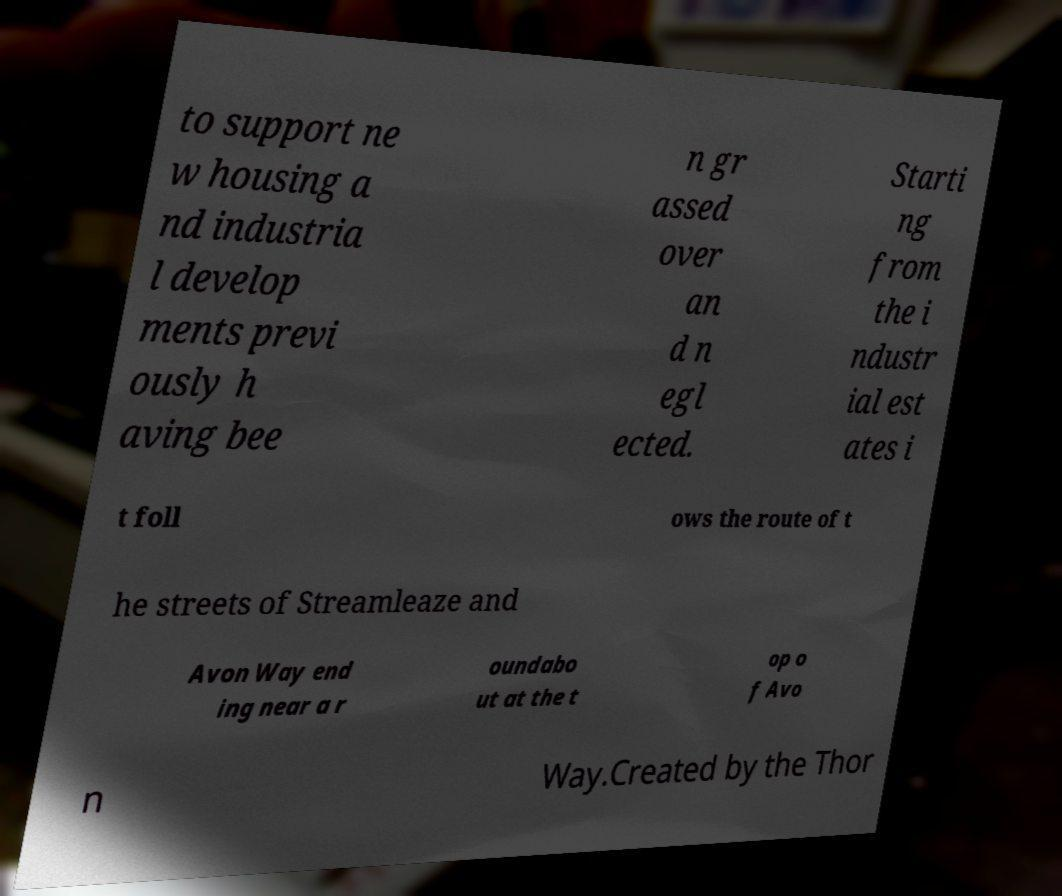What messages or text are displayed in this image? I need them in a readable, typed format. to support ne w housing a nd industria l develop ments previ ously h aving bee n gr assed over an d n egl ected. Starti ng from the i ndustr ial est ates i t foll ows the route of t he streets of Streamleaze and Avon Way end ing near a r oundabo ut at the t op o f Avo n Way.Created by the Thor 